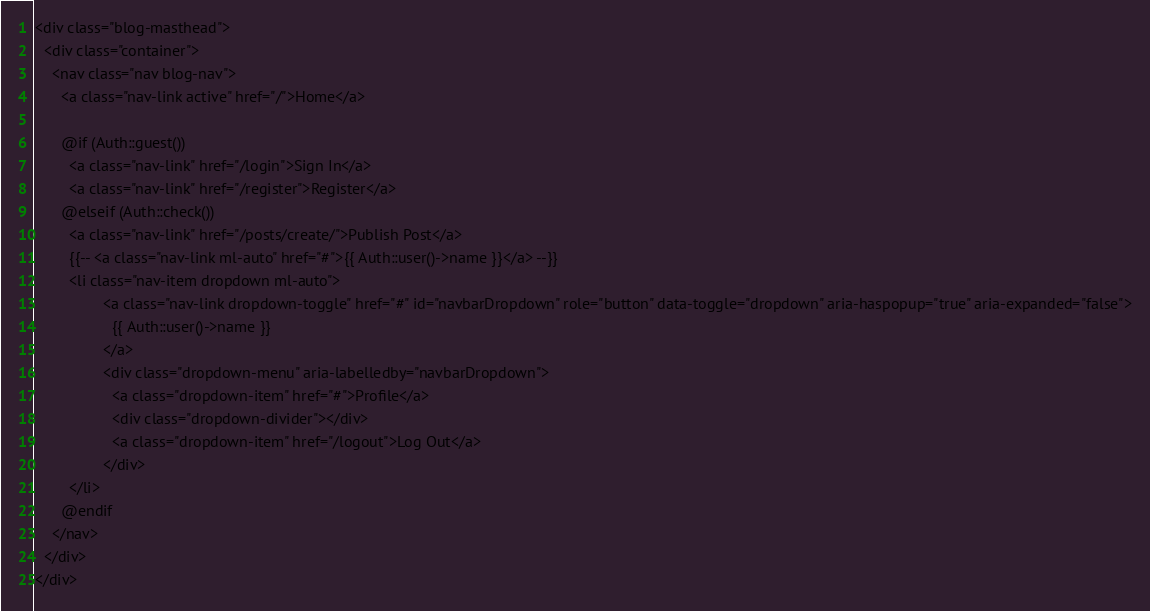<code> <loc_0><loc_0><loc_500><loc_500><_PHP_><div class="blog-masthead">
  <div class="container">
    <nav class="nav blog-nav">
      <a class="nav-link active" href="/">Home</a>

      @if (Auth::guest())
        <a class="nav-link" href="/login">Sign In</a>
        <a class="nav-link" href="/register">Register</a>
      @elseif (Auth::check())
        <a class="nav-link" href="/posts/create/">Publish Post</a>
        {{-- <a class="nav-link ml-auto" href="#">{{ Auth::user()->name }}</a> --}}
        <li class="nav-item dropdown ml-auto">
                <a class="nav-link dropdown-toggle" href="#" id="navbarDropdown" role="button" data-toggle="dropdown" aria-haspopup="true" aria-expanded="false">
                  {{ Auth::user()->name }}
                </a>
                <div class="dropdown-menu" aria-labelledby="navbarDropdown">
                  <a class="dropdown-item" href="#">Profile</a>
                  <div class="dropdown-divider"></div>
                  <a class="dropdown-item" href="/logout">Log Out</a>
                </div>
        </li>
      @endif
    </nav>
  </div>
</div>
</code> 